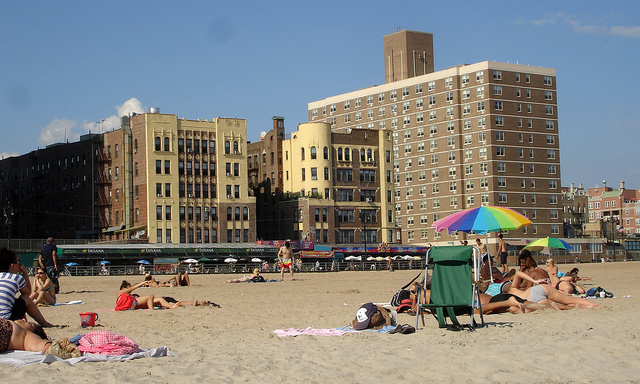Where is someone who might easily overheat safest here?
A. on chair
B. under umbrella
C. in sand
D. water's edge
Answer with the option's letter from the given choices directly. B 